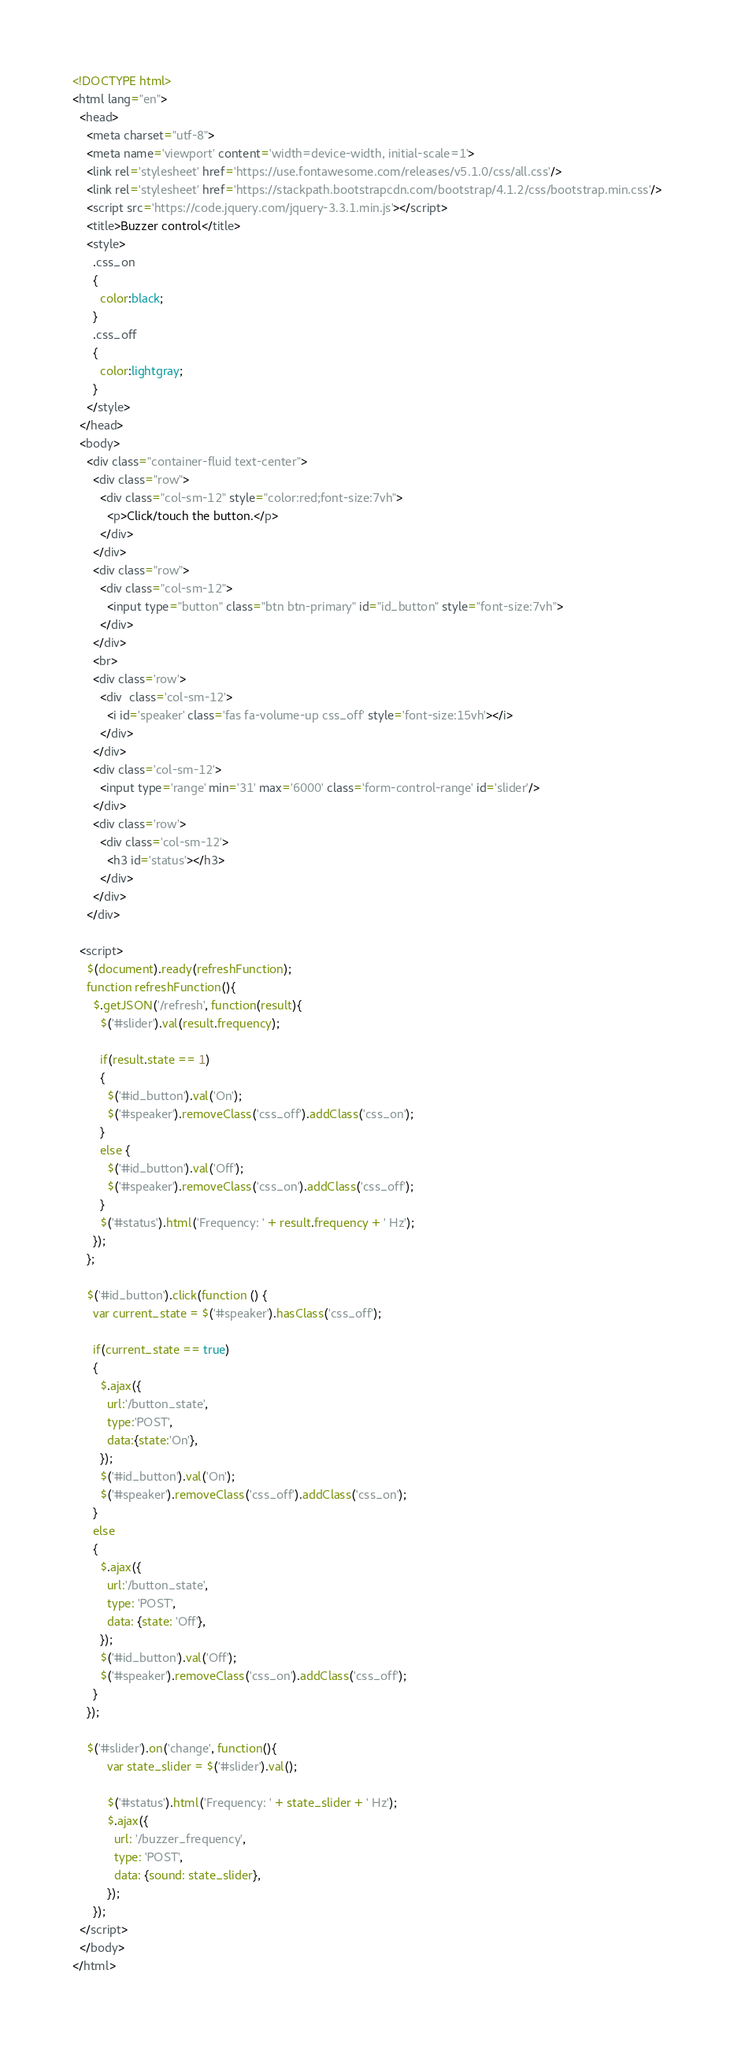Convert code to text. <code><loc_0><loc_0><loc_500><loc_500><_HTML_><!DOCTYPE html>
<html lang="en">
  <head>
    <meta charset="utf-8">
    <meta name='viewport' content='width=device-width, initial-scale=1'>
    <link rel='stylesheet' href='https://use.fontawesome.com/releases/v5.1.0/css/all.css'/>
    <link rel='stylesheet' href='https://stackpath.bootstrapcdn.com/bootstrap/4.1.2/css/bootstrap.min.css'/>
    <script src='https://code.jquery.com/jquery-3.3.1.min.js'></script>
    <title>Buzzer control</title>
    <style>
      .css_on
      {
        color:black;
      }
      .css_off
      {
        color:lightgray;
      }
    </style>
  </head>
  <body>
    <div class="container-fluid text-center">
      <div class="row">
        <div class="col-sm-12" style="color:red;font-size:7vh">
          <p>Click/touch the button.</p>
        </div>
      </div>
      <div class="row">
        <div class="col-sm-12">
          <input type="button" class="btn btn-primary" id="id_button" style="font-size:7vh">
        </div>
      </div>
      <br>
      <div class='row'>
        <div  class='col-sm-12'>
          <i id='speaker' class='fas fa-volume-up css_off' style='font-size:15vh'></i>
        </div>
      </div>
      <div class='col-sm-12'>
        <input type='range' min='31' max='6000' class='form-control-range' id='slider'/>
      </div>
      <div class='row'>
        <div class='col-sm-12'>
          <h3 id='status'></h3>
        </div>
      </div>
    </div>

  <script>
    $(document).ready(refreshFunction);
    function refreshFunction(){
      $.getJSON('/refresh', function(result){
        $('#slider').val(result.frequency);

        if(result.state == 1)
        {
          $('#id_button').val('On');
          $('#speaker').removeClass('css_off').addClass('css_on');
        }
        else {
          $('#id_button').val('Off');
          $('#speaker').removeClass('css_on').addClass('css_off');
        }
        $('#status').html('Frequency: ' + result.frequency + ' Hz');
      });
    };

    $('#id_button').click(function () {
      var current_state = $('#speaker').hasClass('css_off');

      if(current_state == true)
      {
        $.ajax({
          url:'/button_state',
          type:'POST',
          data:{state:'On'},
        });
        $('#id_button').val('On');
        $('#speaker').removeClass('css_off').addClass('css_on');
      }
      else
      {
        $.ajax({
          url:'/button_state',
          type: 'POST',
          data: {state: 'Off'},
        });
        $('#id_button').val('Off');
        $('#speaker').removeClass('css_on').addClass('css_off');
      }
    });

    $('#slider').on('change', function(){
          var state_slider = $('#slider').val();

          $('#status').html('Frequency: ' + state_slider + ' Hz');
          $.ajax({
            url: '/buzzer_frequency',
            type: 'POST',
            data: {sound: state_slider},
          });
      });
  </script>
  </body>
</html>
</code> 